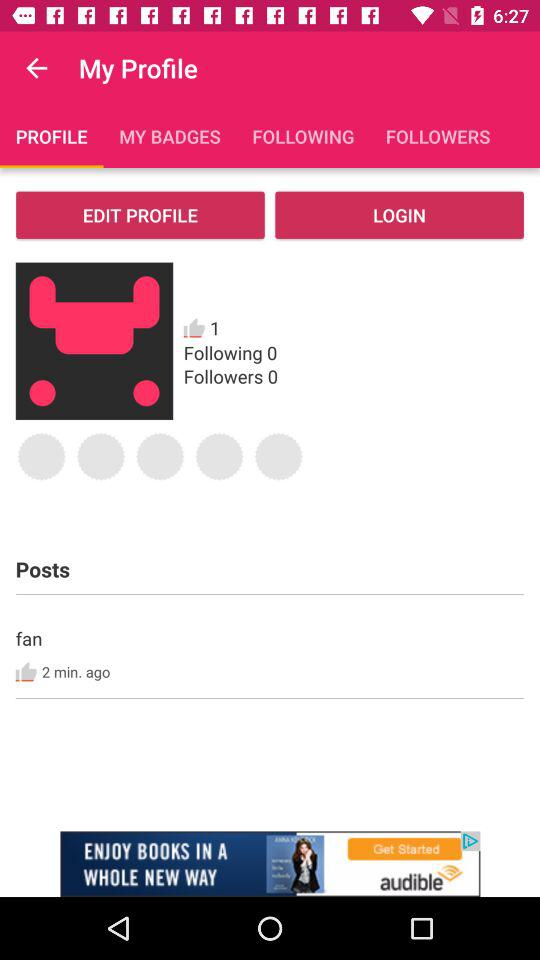What is the number of people the user follows? The user follows 0 people. 